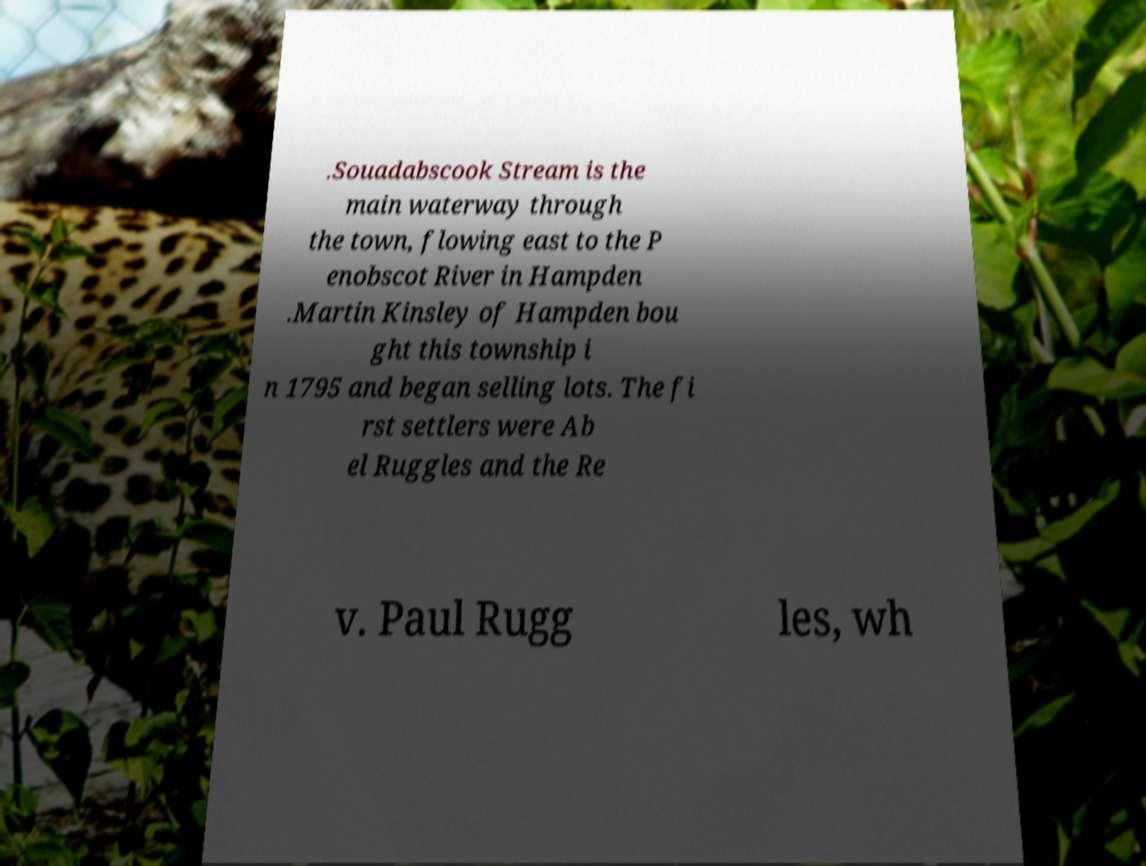Can you read and provide the text displayed in the image?This photo seems to have some interesting text. Can you extract and type it out for me? .Souadabscook Stream is the main waterway through the town, flowing east to the P enobscot River in Hampden .Martin Kinsley of Hampden bou ght this township i n 1795 and began selling lots. The fi rst settlers were Ab el Ruggles and the Re v. Paul Rugg les, wh 